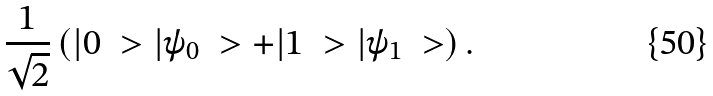Convert formula to latex. <formula><loc_0><loc_0><loc_500><loc_500>\frac { 1 } { \sqrt { 2 } } \left ( | 0 \ > | \psi _ { 0 } \ > + | 1 \ > | \psi _ { 1 } \ > \right ) .</formula> 